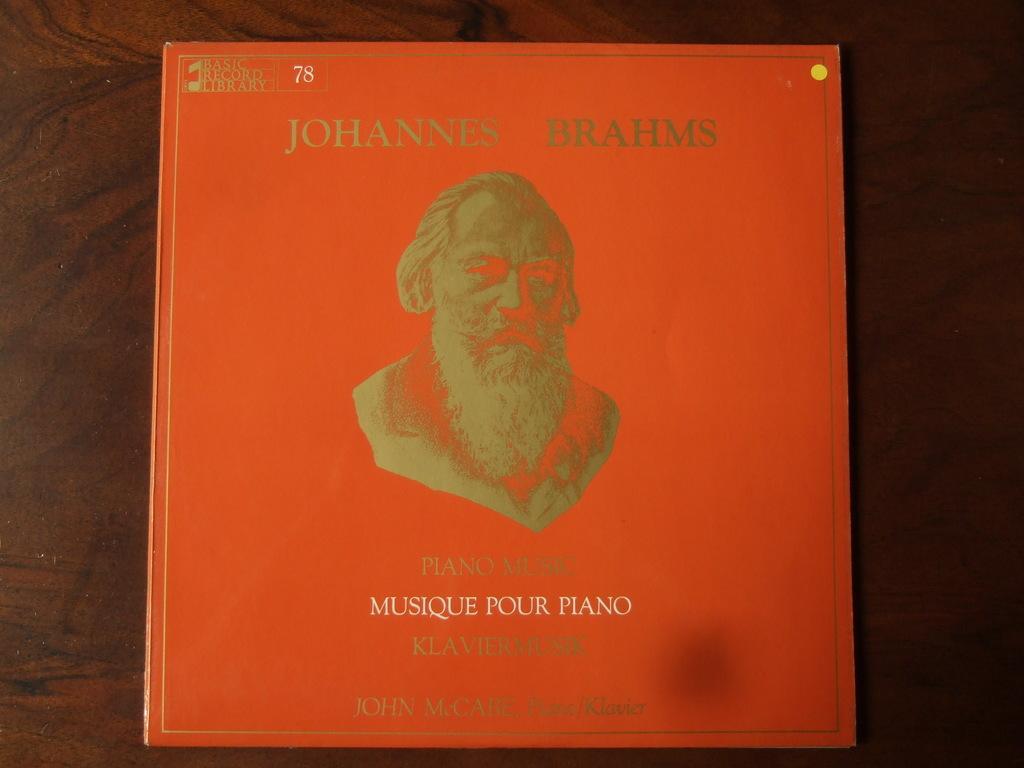Describe this image in one or two sentences. In the middle of the image we can see a book, in the book we can find some text and a man. 